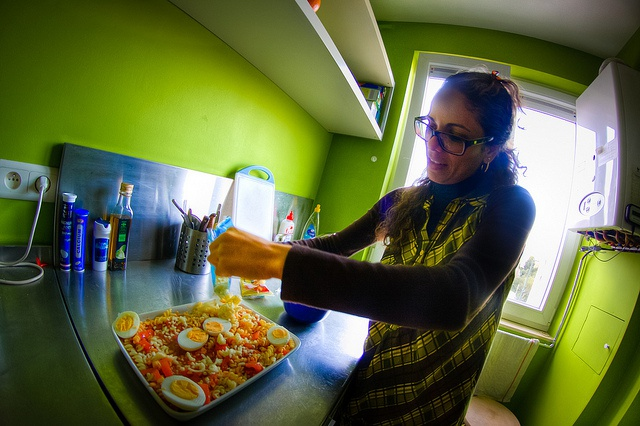Describe the objects in this image and their specific colors. I can see people in black, olive, navy, and maroon tones, bottle in black, maroon, blue, and olive tones, bottle in black, navy, darkblue, and blue tones, bowl in black, navy, purple, and darkblue tones, and bottle in black, lavender, darkgray, red, and lightblue tones in this image. 